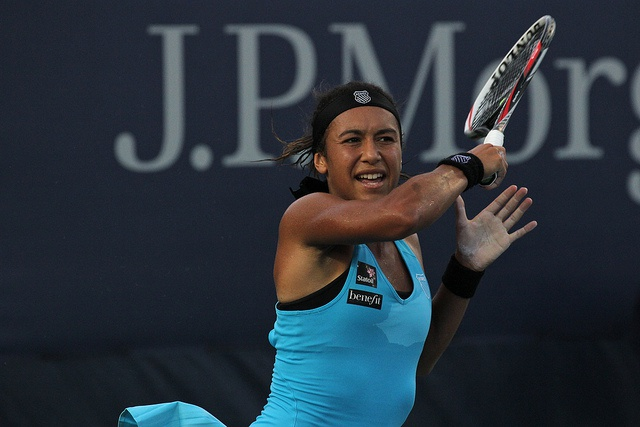Describe the objects in this image and their specific colors. I can see people in black, teal, and brown tones and tennis racket in black, gray, darkgray, and lightgray tones in this image. 